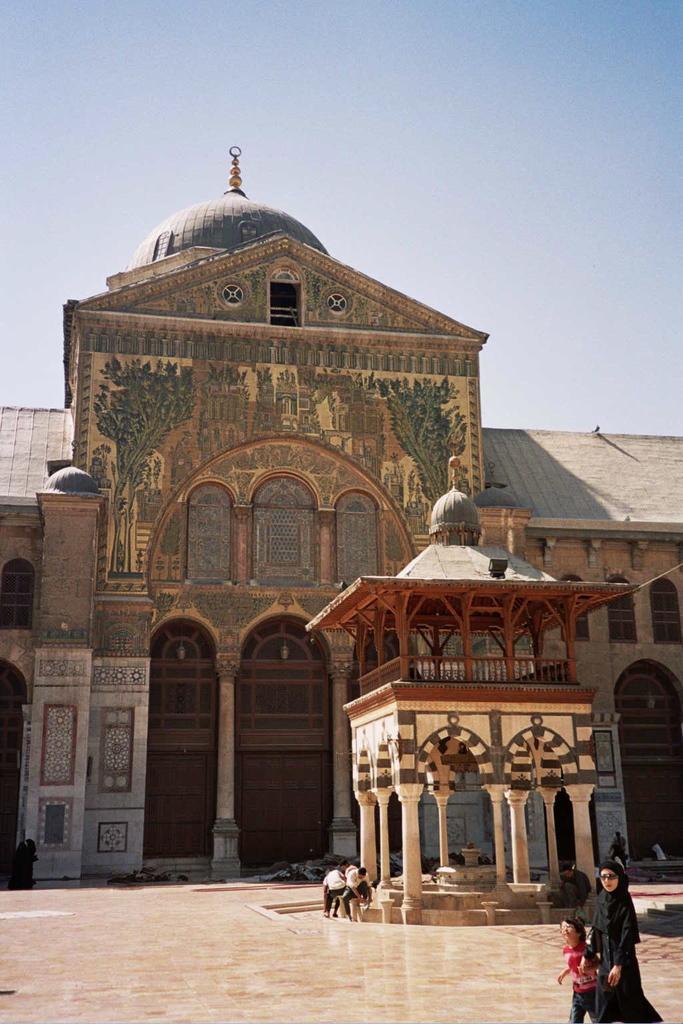How would you summarize this image in a sentence or two? In this image at the bottom we can see two persons and there are few persons at the gazebo. In the background there is a building, doors, windows, designs on the walls, roof and sky. 